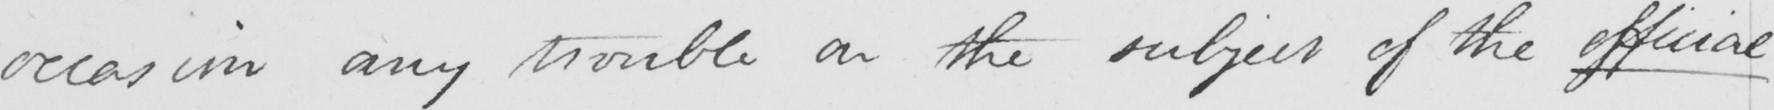What text is written in this handwritten line? occasion any trouble on the subject of the official 